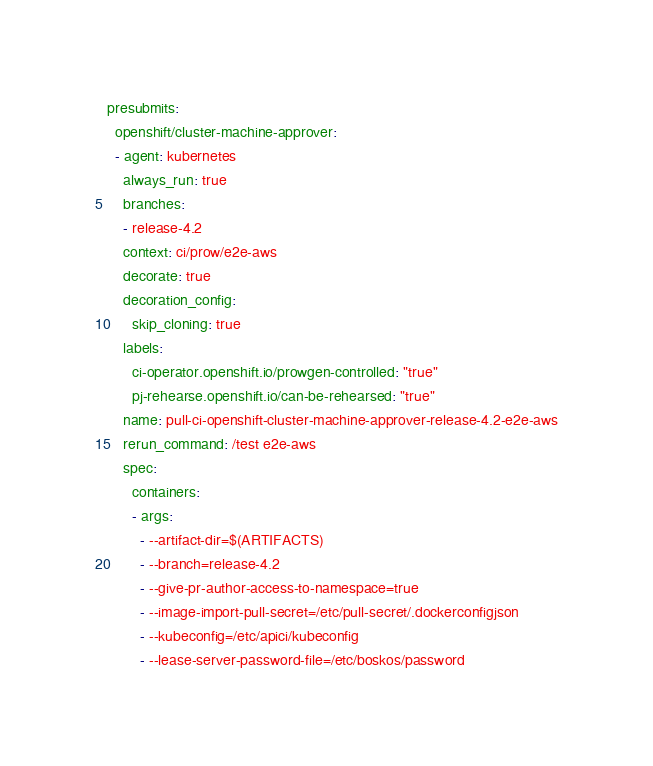Convert code to text. <code><loc_0><loc_0><loc_500><loc_500><_YAML_>presubmits:
  openshift/cluster-machine-approver:
  - agent: kubernetes
    always_run: true
    branches:
    - release-4.2
    context: ci/prow/e2e-aws
    decorate: true
    decoration_config:
      skip_cloning: true
    labels:
      ci-operator.openshift.io/prowgen-controlled: "true"
      pj-rehearse.openshift.io/can-be-rehearsed: "true"
    name: pull-ci-openshift-cluster-machine-approver-release-4.2-e2e-aws
    rerun_command: /test e2e-aws
    spec:
      containers:
      - args:
        - --artifact-dir=$(ARTIFACTS)
        - --branch=release-4.2
        - --give-pr-author-access-to-namespace=true
        - --image-import-pull-secret=/etc/pull-secret/.dockerconfigjson
        - --kubeconfig=/etc/apici/kubeconfig
        - --lease-server-password-file=/etc/boskos/password</code> 